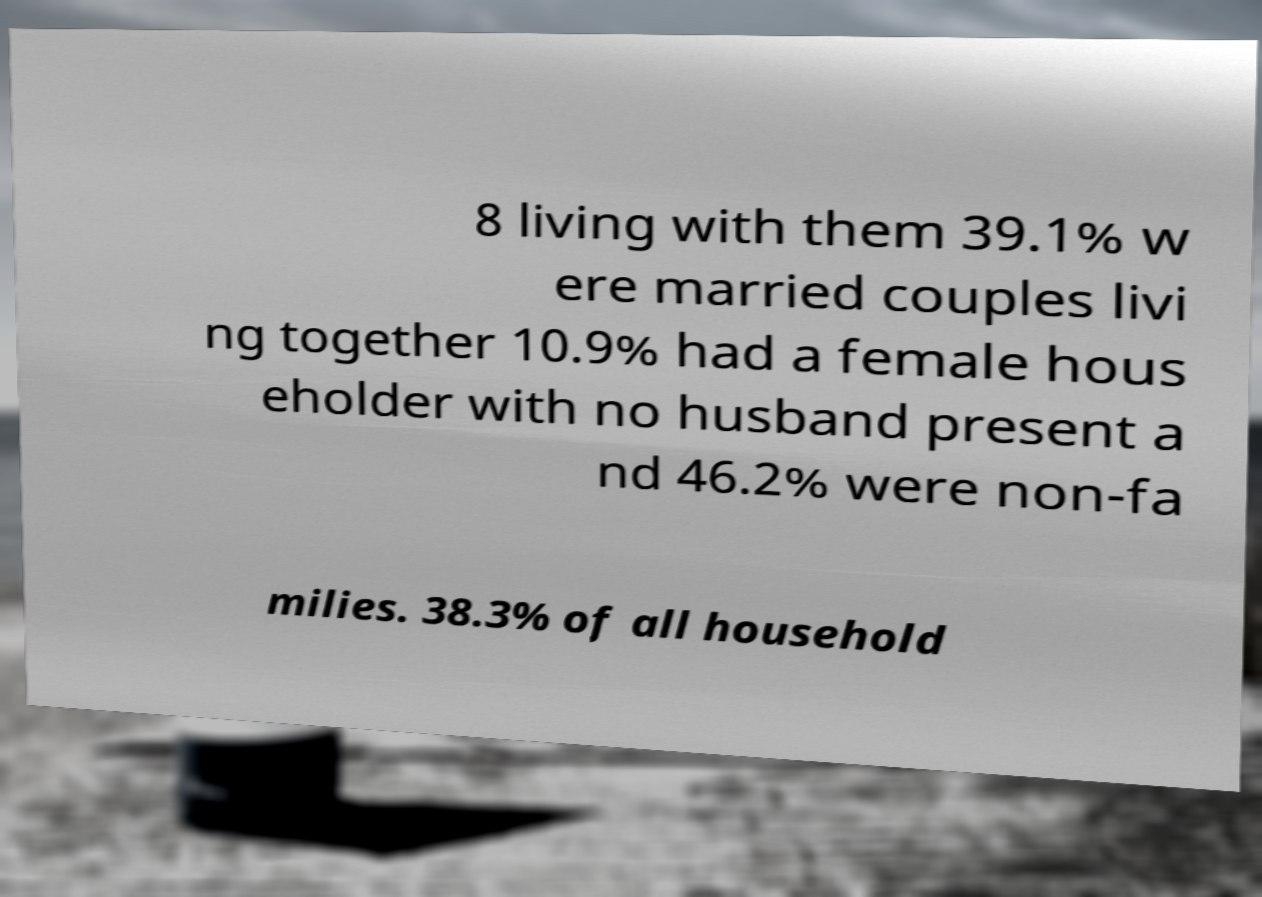For documentation purposes, I need the text within this image transcribed. Could you provide that? 8 living with them 39.1% w ere married couples livi ng together 10.9% had a female hous eholder with no husband present a nd 46.2% were non-fa milies. 38.3% of all household 